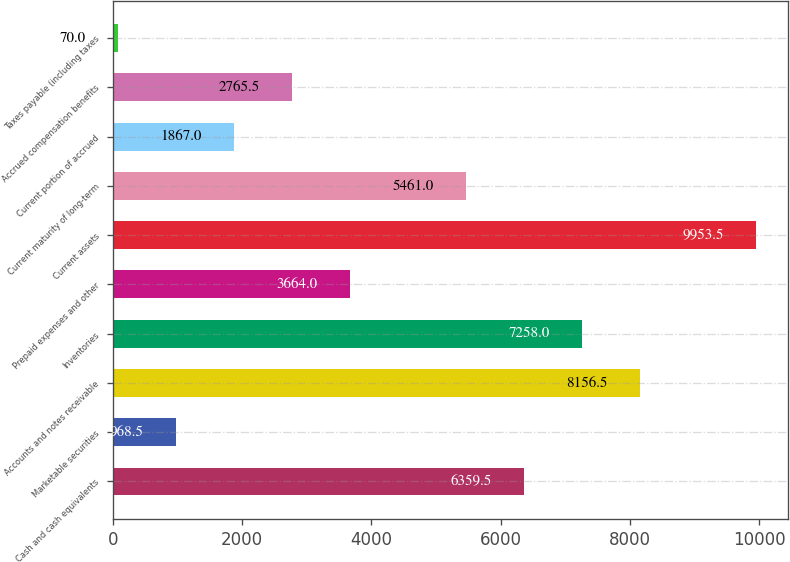Convert chart. <chart><loc_0><loc_0><loc_500><loc_500><bar_chart><fcel>Cash and cash equivalents<fcel>Marketable securities<fcel>Accounts and notes receivable<fcel>Inventories<fcel>Prepaid expenses and other<fcel>Current assets<fcel>Current maturity of long-term<fcel>Current portion of accrued<fcel>Accrued compensation benefits<fcel>Taxes payable (including taxes<nl><fcel>6359.5<fcel>968.5<fcel>8156.5<fcel>7258<fcel>3664<fcel>9953.5<fcel>5461<fcel>1867<fcel>2765.5<fcel>70<nl></chart> 